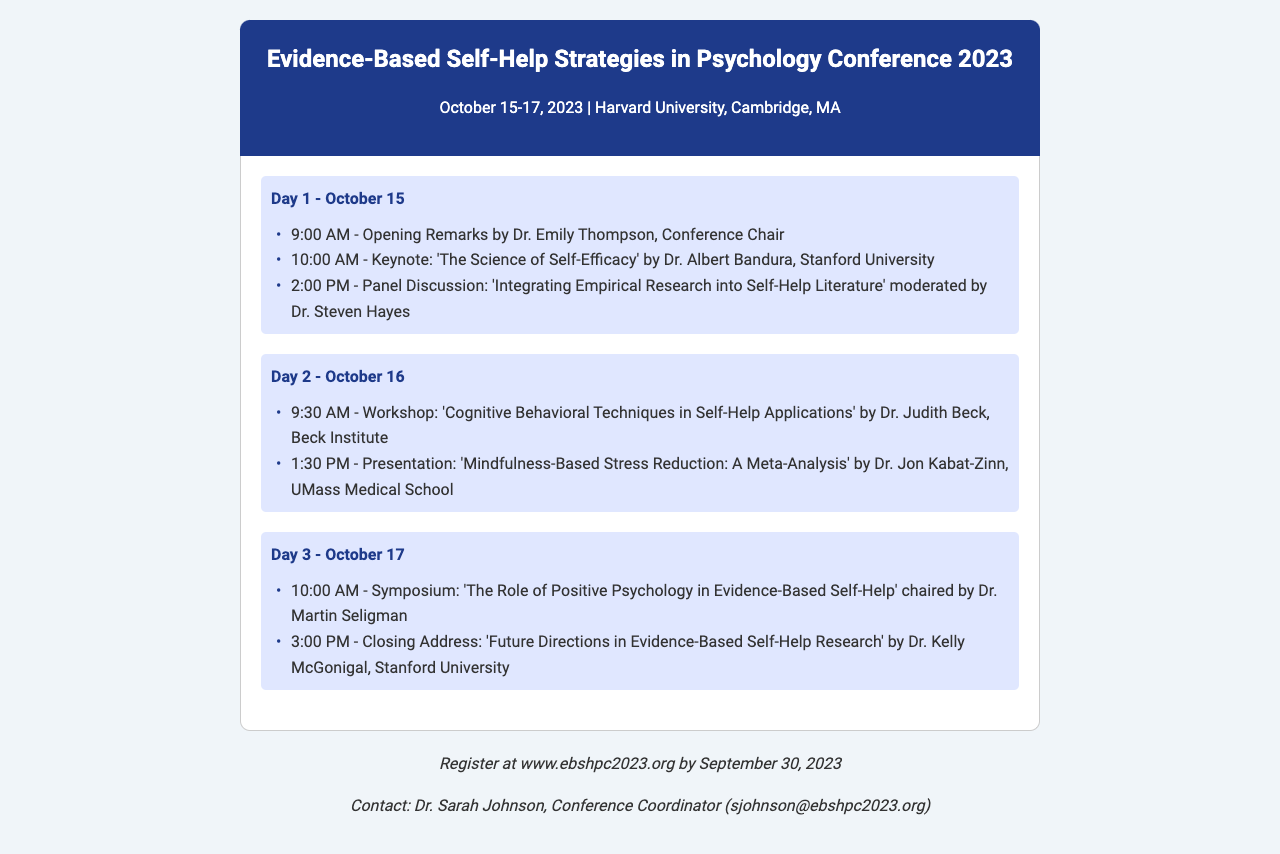What are the dates of the conference? The conference is scheduled for October 15-17, 2023, as stated at the beginning of the document.
Answer: October 15-17, 2023 Who is the keynote speaker? The keynote speaker is Dr. Albert Bandura from Stanford University, mentioned in the first day's agenda.
Answer: Dr. Albert Bandura What is the topic of the panel discussion on Day 1? The topic is 'Integrating Empirical Research into Self-Help Literature', which is specified under Day 1 events.
Answer: Integrating Empirical Research into Self-Help Literature Which workshop is scheduled for Day 2? The workshop titled 'Cognitive Behavioral Techniques in Self-Help Applications' is outlined for Day 2.
Answer: Cognitive Behavioral Techniques in Self-Help Applications Who will chair the symposium on Day 3? The symposium is chaired by Dr. Martin Seligman, as mentioned in the Day 3 events.
Answer: Dr. Martin Seligman What time does the closing address begin on Day 3? The closing address starts at 3:00 PM, according to the Day 3 schedule.
Answer: 3:00 PM What institution is Dr. Judith Beck affiliated with? Dr. Judith Beck is associated with the Beck Institute, as referenced in the Day 2 workshop.
Answer: Beck Institute What is the deadline for conference registration? The registration deadline is specified as September 30, 2023, in the footer of the document.
Answer: September 30, 2023 Who is the conference coordinator? The conference coordinator is Dr. Sarah Johnson, as noted in the contact information section.
Answer: Dr. Sarah Johnson 